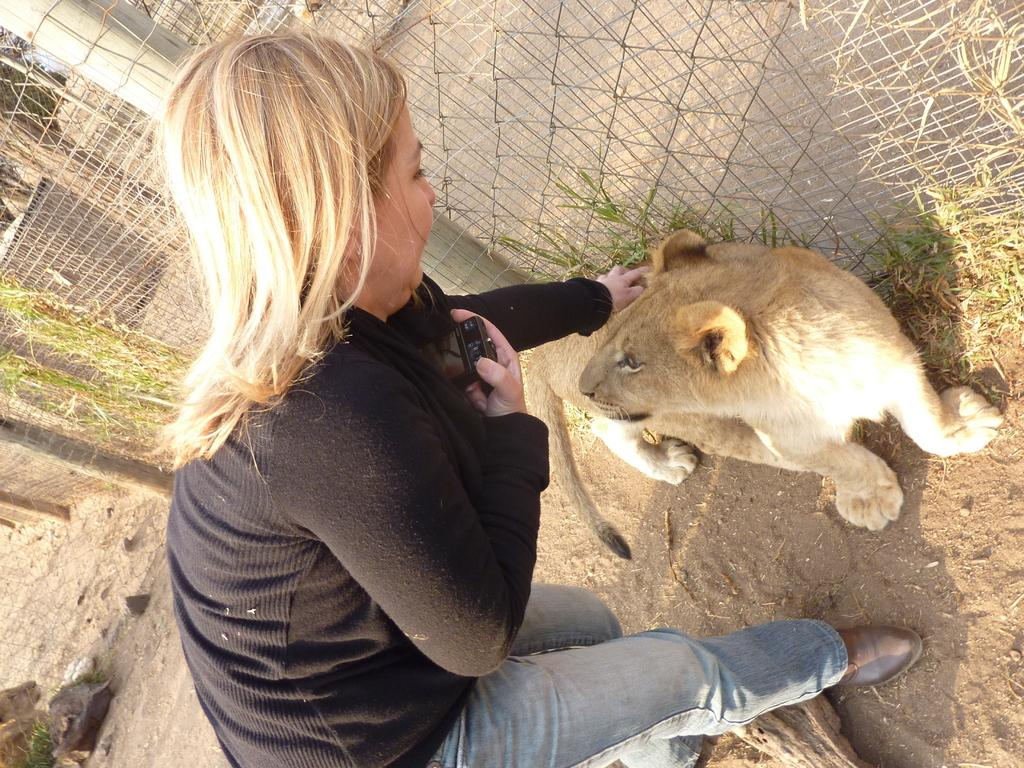What type of animals can be seen on the ground in the image? There are animals on the ground in the image, but their specific type is not mentioned in the facts. What is the woman in the image holding? The woman is holding a camera in her hand. What can be seen in the background of the image? In the background of the image, there is a fence, a pole, and plants. What type of toy can be seen on the ground in the image? There is no toy present on the ground in the image. What type of glass is being used by the woman in the image? The woman is holding a camera, not a glass, in her hand. 